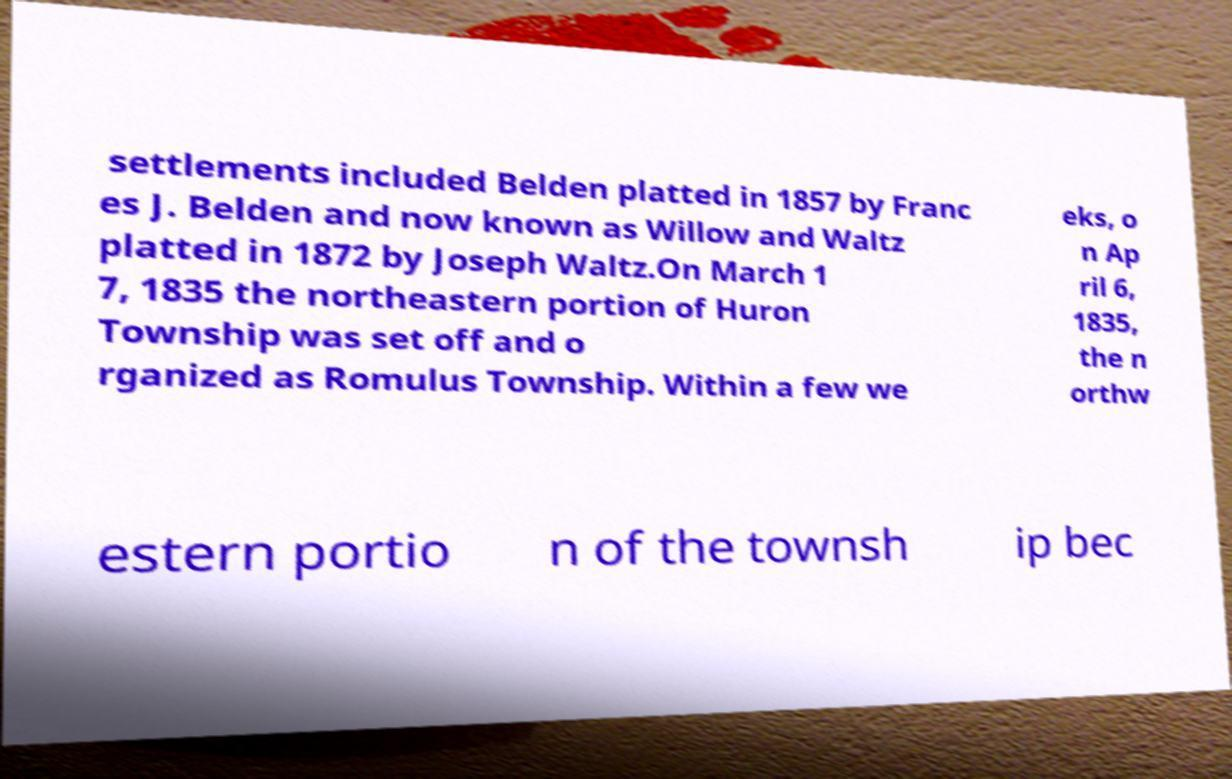Please identify and transcribe the text found in this image. settlements included Belden platted in 1857 by Franc es J. Belden and now known as Willow and Waltz platted in 1872 by Joseph Waltz.On March 1 7, 1835 the northeastern portion of Huron Township was set off and o rganized as Romulus Township. Within a few we eks, o n Ap ril 6, 1835, the n orthw estern portio n of the townsh ip bec 